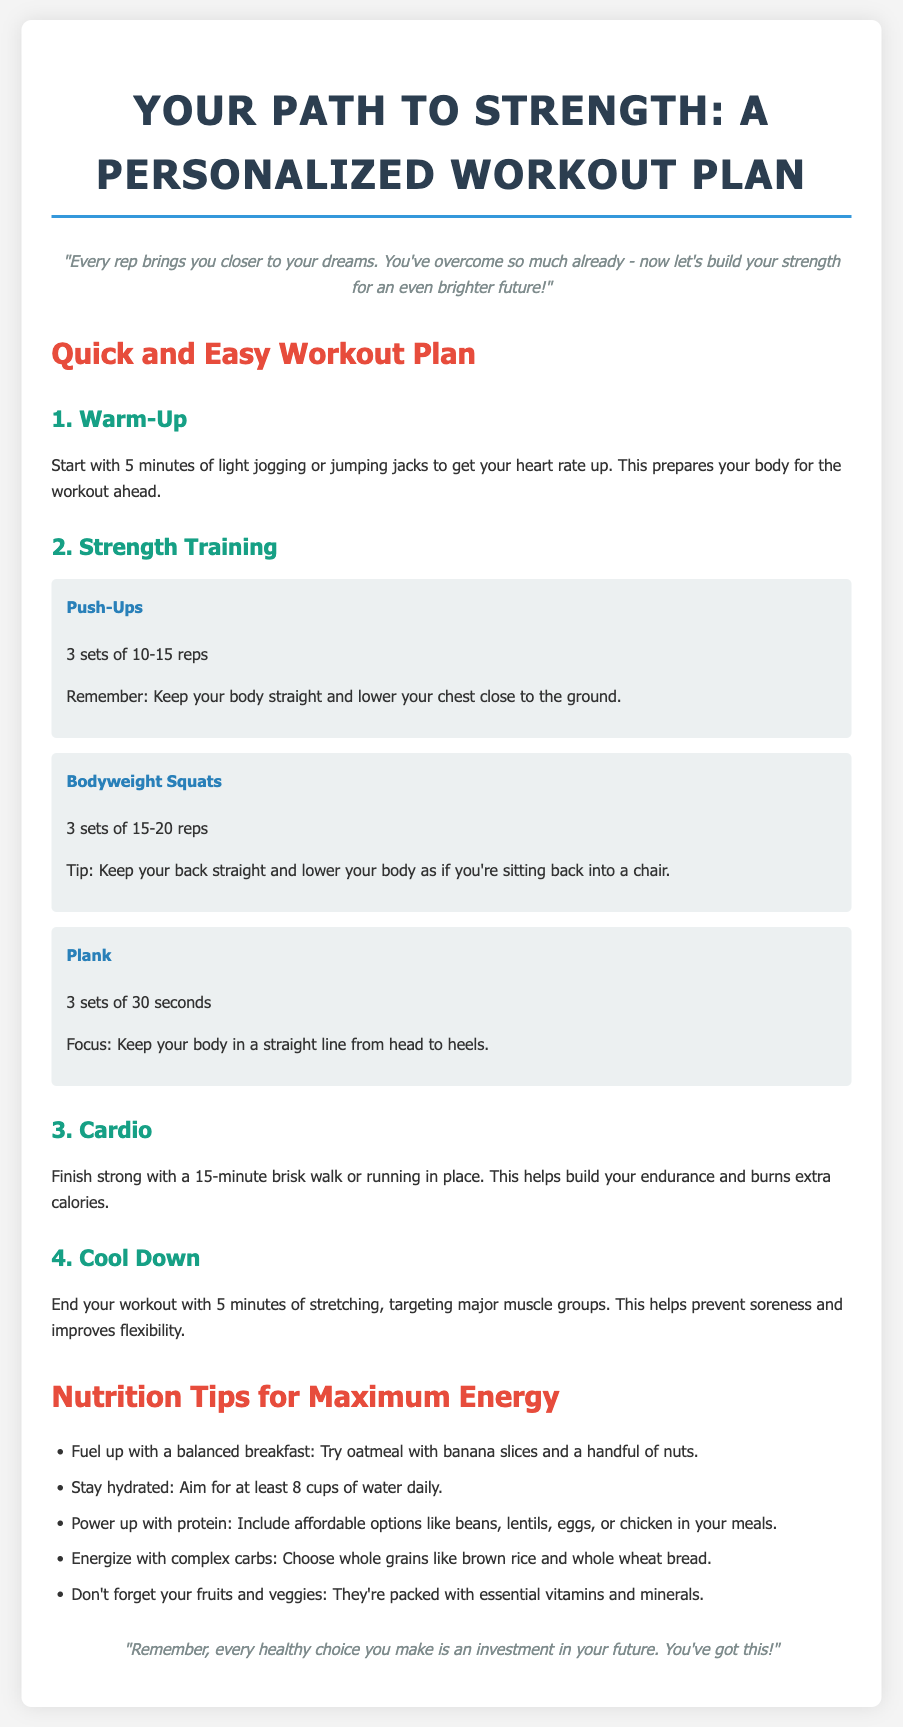what is the title of the document? The title of the document is stated at the top, which indicates the focus of the content.
Answer: Your Path to Strength: A Personalized Workout Plan how many sets of push-ups are recommended? The document specifies the number of sets recommended for push-ups, providing clear instructions for the workout.
Answer: 3 sets what is a suggested breakfast option? The document provides specific nutrition tips, including options for a balanced meal, which helps in setting a solid dietary foundation.
Answer: oatmeal with banana slices and a handful of nuts how long should the cool down last? The document recommends a duration for the cool down to ensure proper recovery after the workout.
Answer: 5 minutes which exercise focuses on core strength? The document describes specific exercises that each target different muscle groups, and one is dedicated to core stability.
Answer: Plank what is the daily water intake recommendation? The document offers hydration advice, which is essential for maintaining overall health and performance, specifying a quantity.
Answer: 8 cups what type of carbohydrates should be included in meals? The document emphasizes the importance of certain nutrition elements, highlighting the preferred source of carbohydrates.
Answer: complex carbs how many minutes should the cardio session last? The document clearly outlines the duration for the cardio activity, guiding users on how to structure their workout.
Answer: 15 minutes 